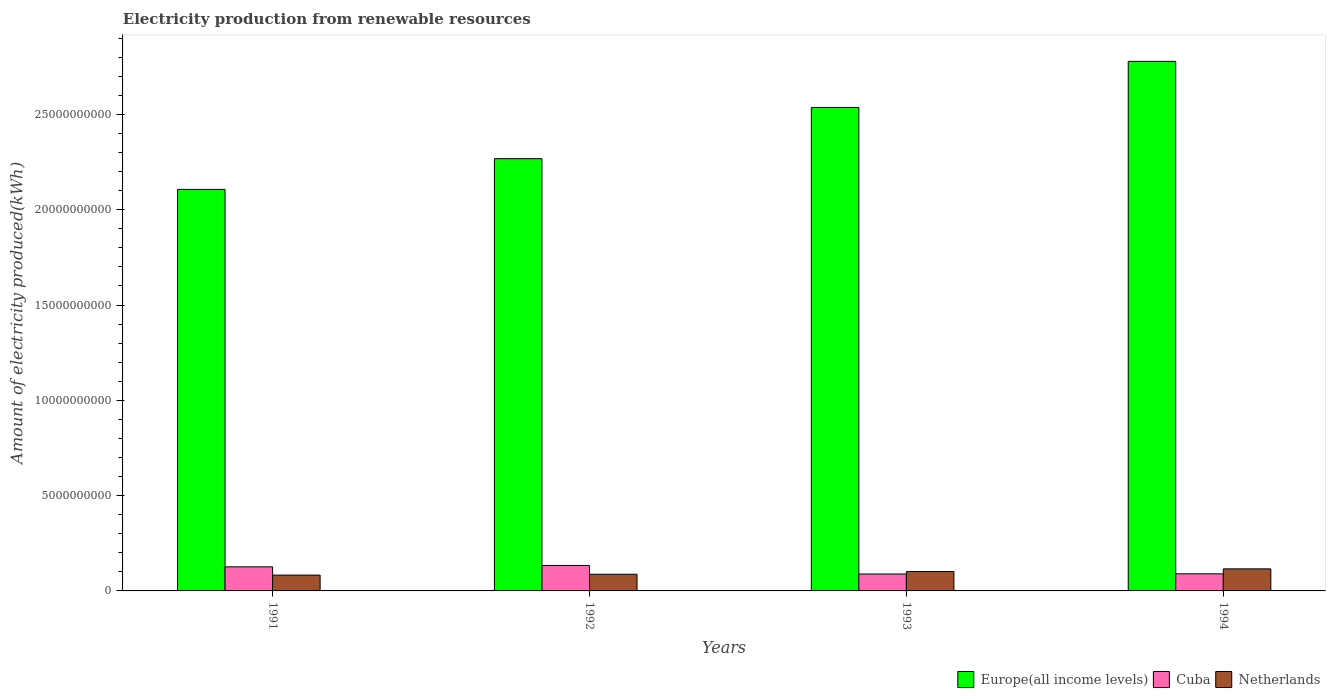Are the number of bars on each tick of the X-axis equal?
Make the answer very short. Yes. How many bars are there on the 2nd tick from the right?
Provide a short and direct response. 3. What is the amount of electricity produced in Netherlands in 1991?
Your response must be concise. 8.30e+08. Across all years, what is the maximum amount of electricity produced in Netherlands?
Your answer should be compact. 1.16e+09. Across all years, what is the minimum amount of electricity produced in Cuba?
Offer a very short reply. 8.87e+08. In which year was the amount of electricity produced in Europe(all income levels) maximum?
Offer a terse response. 1994. What is the total amount of electricity produced in Europe(all income levels) in the graph?
Your response must be concise. 9.69e+1. What is the difference between the amount of electricity produced in Netherlands in 1991 and that in 1994?
Keep it short and to the point. -3.27e+08. What is the difference between the amount of electricity produced in Europe(all income levels) in 1991 and the amount of electricity produced in Cuba in 1994?
Provide a succinct answer. 2.02e+1. What is the average amount of electricity produced in Netherlands per year?
Keep it short and to the point. 9.69e+08. In the year 1993, what is the difference between the amount of electricity produced in Europe(all income levels) and amount of electricity produced in Netherlands?
Make the answer very short. 2.44e+1. In how many years, is the amount of electricity produced in Europe(all income levels) greater than 20000000000 kWh?
Make the answer very short. 4. What is the ratio of the amount of electricity produced in Netherlands in 1993 to that in 1994?
Ensure brevity in your answer.  0.88. Is the difference between the amount of electricity produced in Europe(all income levels) in 1991 and 1992 greater than the difference between the amount of electricity produced in Netherlands in 1991 and 1992?
Ensure brevity in your answer.  No. What is the difference between the highest and the second highest amount of electricity produced in Netherlands?
Give a very brief answer. 1.42e+08. What is the difference between the highest and the lowest amount of electricity produced in Netherlands?
Ensure brevity in your answer.  3.27e+08. What does the 1st bar from the left in 1992 represents?
Make the answer very short. Europe(all income levels). What does the 2nd bar from the right in 1992 represents?
Provide a succinct answer. Cuba. Is it the case that in every year, the sum of the amount of electricity produced in Netherlands and amount of electricity produced in Europe(all income levels) is greater than the amount of electricity produced in Cuba?
Provide a short and direct response. Yes. How many bars are there?
Give a very brief answer. 12. Are all the bars in the graph horizontal?
Offer a terse response. No. How many years are there in the graph?
Provide a succinct answer. 4. Are the values on the major ticks of Y-axis written in scientific E-notation?
Your response must be concise. No. Does the graph contain any zero values?
Offer a very short reply. No. Does the graph contain grids?
Your answer should be very brief. No. How many legend labels are there?
Provide a succinct answer. 3. How are the legend labels stacked?
Offer a terse response. Horizontal. What is the title of the graph?
Ensure brevity in your answer.  Electricity production from renewable resources. What is the label or title of the Y-axis?
Make the answer very short. Amount of electricity produced(kWh). What is the Amount of electricity produced(kWh) of Europe(all income levels) in 1991?
Keep it short and to the point. 2.11e+1. What is the Amount of electricity produced(kWh) in Cuba in 1991?
Your answer should be very brief. 1.26e+09. What is the Amount of electricity produced(kWh) in Netherlands in 1991?
Give a very brief answer. 8.30e+08. What is the Amount of electricity produced(kWh) of Europe(all income levels) in 1992?
Ensure brevity in your answer.  2.27e+1. What is the Amount of electricity produced(kWh) in Cuba in 1992?
Offer a terse response. 1.34e+09. What is the Amount of electricity produced(kWh) in Netherlands in 1992?
Offer a terse response. 8.75e+08. What is the Amount of electricity produced(kWh) of Europe(all income levels) in 1993?
Give a very brief answer. 2.54e+1. What is the Amount of electricity produced(kWh) in Cuba in 1993?
Give a very brief answer. 8.87e+08. What is the Amount of electricity produced(kWh) of Netherlands in 1993?
Offer a terse response. 1.02e+09. What is the Amount of electricity produced(kWh) in Europe(all income levels) in 1994?
Provide a succinct answer. 2.78e+1. What is the Amount of electricity produced(kWh) in Cuba in 1994?
Give a very brief answer. 8.97e+08. What is the Amount of electricity produced(kWh) of Netherlands in 1994?
Provide a short and direct response. 1.16e+09. Across all years, what is the maximum Amount of electricity produced(kWh) in Europe(all income levels)?
Ensure brevity in your answer.  2.78e+1. Across all years, what is the maximum Amount of electricity produced(kWh) of Cuba?
Your answer should be compact. 1.34e+09. Across all years, what is the maximum Amount of electricity produced(kWh) in Netherlands?
Your answer should be very brief. 1.16e+09. Across all years, what is the minimum Amount of electricity produced(kWh) in Europe(all income levels)?
Provide a succinct answer. 2.11e+1. Across all years, what is the minimum Amount of electricity produced(kWh) of Cuba?
Give a very brief answer. 8.87e+08. Across all years, what is the minimum Amount of electricity produced(kWh) of Netherlands?
Your response must be concise. 8.30e+08. What is the total Amount of electricity produced(kWh) of Europe(all income levels) in the graph?
Your response must be concise. 9.69e+1. What is the total Amount of electricity produced(kWh) of Cuba in the graph?
Keep it short and to the point. 4.38e+09. What is the total Amount of electricity produced(kWh) of Netherlands in the graph?
Provide a succinct answer. 3.88e+09. What is the difference between the Amount of electricity produced(kWh) in Europe(all income levels) in 1991 and that in 1992?
Provide a succinct answer. -1.61e+09. What is the difference between the Amount of electricity produced(kWh) in Cuba in 1991 and that in 1992?
Keep it short and to the point. -7.30e+07. What is the difference between the Amount of electricity produced(kWh) of Netherlands in 1991 and that in 1992?
Give a very brief answer. -4.50e+07. What is the difference between the Amount of electricity produced(kWh) of Europe(all income levels) in 1991 and that in 1993?
Give a very brief answer. -4.30e+09. What is the difference between the Amount of electricity produced(kWh) in Cuba in 1991 and that in 1993?
Your answer should be compact. 3.77e+08. What is the difference between the Amount of electricity produced(kWh) of Netherlands in 1991 and that in 1993?
Make the answer very short. -1.85e+08. What is the difference between the Amount of electricity produced(kWh) of Europe(all income levels) in 1991 and that in 1994?
Give a very brief answer. -6.72e+09. What is the difference between the Amount of electricity produced(kWh) of Cuba in 1991 and that in 1994?
Offer a very short reply. 3.67e+08. What is the difference between the Amount of electricity produced(kWh) of Netherlands in 1991 and that in 1994?
Offer a very short reply. -3.27e+08. What is the difference between the Amount of electricity produced(kWh) in Europe(all income levels) in 1992 and that in 1993?
Keep it short and to the point. -2.69e+09. What is the difference between the Amount of electricity produced(kWh) of Cuba in 1992 and that in 1993?
Offer a very short reply. 4.50e+08. What is the difference between the Amount of electricity produced(kWh) in Netherlands in 1992 and that in 1993?
Offer a terse response. -1.40e+08. What is the difference between the Amount of electricity produced(kWh) of Europe(all income levels) in 1992 and that in 1994?
Ensure brevity in your answer.  -5.11e+09. What is the difference between the Amount of electricity produced(kWh) of Cuba in 1992 and that in 1994?
Provide a short and direct response. 4.40e+08. What is the difference between the Amount of electricity produced(kWh) of Netherlands in 1992 and that in 1994?
Keep it short and to the point. -2.82e+08. What is the difference between the Amount of electricity produced(kWh) in Europe(all income levels) in 1993 and that in 1994?
Give a very brief answer. -2.42e+09. What is the difference between the Amount of electricity produced(kWh) in Cuba in 1993 and that in 1994?
Keep it short and to the point. -1.00e+07. What is the difference between the Amount of electricity produced(kWh) of Netherlands in 1993 and that in 1994?
Keep it short and to the point. -1.42e+08. What is the difference between the Amount of electricity produced(kWh) in Europe(all income levels) in 1991 and the Amount of electricity produced(kWh) in Cuba in 1992?
Ensure brevity in your answer.  1.97e+1. What is the difference between the Amount of electricity produced(kWh) in Europe(all income levels) in 1991 and the Amount of electricity produced(kWh) in Netherlands in 1992?
Provide a short and direct response. 2.02e+1. What is the difference between the Amount of electricity produced(kWh) in Cuba in 1991 and the Amount of electricity produced(kWh) in Netherlands in 1992?
Your answer should be very brief. 3.89e+08. What is the difference between the Amount of electricity produced(kWh) in Europe(all income levels) in 1991 and the Amount of electricity produced(kWh) in Cuba in 1993?
Your response must be concise. 2.02e+1. What is the difference between the Amount of electricity produced(kWh) in Europe(all income levels) in 1991 and the Amount of electricity produced(kWh) in Netherlands in 1993?
Your response must be concise. 2.01e+1. What is the difference between the Amount of electricity produced(kWh) in Cuba in 1991 and the Amount of electricity produced(kWh) in Netherlands in 1993?
Your answer should be very brief. 2.49e+08. What is the difference between the Amount of electricity produced(kWh) in Europe(all income levels) in 1991 and the Amount of electricity produced(kWh) in Cuba in 1994?
Give a very brief answer. 2.02e+1. What is the difference between the Amount of electricity produced(kWh) in Europe(all income levels) in 1991 and the Amount of electricity produced(kWh) in Netherlands in 1994?
Your answer should be compact. 1.99e+1. What is the difference between the Amount of electricity produced(kWh) of Cuba in 1991 and the Amount of electricity produced(kWh) of Netherlands in 1994?
Offer a very short reply. 1.07e+08. What is the difference between the Amount of electricity produced(kWh) in Europe(all income levels) in 1992 and the Amount of electricity produced(kWh) in Cuba in 1993?
Offer a very short reply. 2.18e+1. What is the difference between the Amount of electricity produced(kWh) of Europe(all income levels) in 1992 and the Amount of electricity produced(kWh) of Netherlands in 1993?
Make the answer very short. 2.17e+1. What is the difference between the Amount of electricity produced(kWh) in Cuba in 1992 and the Amount of electricity produced(kWh) in Netherlands in 1993?
Provide a succinct answer. 3.22e+08. What is the difference between the Amount of electricity produced(kWh) in Europe(all income levels) in 1992 and the Amount of electricity produced(kWh) in Cuba in 1994?
Offer a very short reply. 2.18e+1. What is the difference between the Amount of electricity produced(kWh) of Europe(all income levels) in 1992 and the Amount of electricity produced(kWh) of Netherlands in 1994?
Provide a short and direct response. 2.15e+1. What is the difference between the Amount of electricity produced(kWh) of Cuba in 1992 and the Amount of electricity produced(kWh) of Netherlands in 1994?
Provide a succinct answer. 1.80e+08. What is the difference between the Amount of electricity produced(kWh) of Europe(all income levels) in 1993 and the Amount of electricity produced(kWh) of Cuba in 1994?
Your answer should be very brief. 2.45e+1. What is the difference between the Amount of electricity produced(kWh) of Europe(all income levels) in 1993 and the Amount of electricity produced(kWh) of Netherlands in 1994?
Provide a short and direct response. 2.42e+1. What is the difference between the Amount of electricity produced(kWh) in Cuba in 1993 and the Amount of electricity produced(kWh) in Netherlands in 1994?
Your answer should be compact. -2.70e+08. What is the average Amount of electricity produced(kWh) of Europe(all income levels) per year?
Ensure brevity in your answer.  2.42e+1. What is the average Amount of electricity produced(kWh) of Cuba per year?
Provide a succinct answer. 1.10e+09. What is the average Amount of electricity produced(kWh) of Netherlands per year?
Keep it short and to the point. 9.69e+08. In the year 1991, what is the difference between the Amount of electricity produced(kWh) in Europe(all income levels) and Amount of electricity produced(kWh) in Cuba?
Offer a very short reply. 1.98e+1. In the year 1991, what is the difference between the Amount of electricity produced(kWh) in Europe(all income levels) and Amount of electricity produced(kWh) in Netherlands?
Offer a very short reply. 2.02e+1. In the year 1991, what is the difference between the Amount of electricity produced(kWh) of Cuba and Amount of electricity produced(kWh) of Netherlands?
Provide a succinct answer. 4.34e+08. In the year 1992, what is the difference between the Amount of electricity produced(kWh) of Europe(all income levels) and Amount of electricity produced(kWh) of Cuba?
Offer a terse response. 2.13e+1. In the year 1992, what is the difference between the Amount of electricity produced(kWh) of Europe(all income levels) and Amount of electricity produced(kWh) of Netherlands?
Ensure brevity in your answer.  2.18e+1. In the year 1992, what is the difference between the Amount of electricity produced(kWh) of Cuba and Amount of electricity produced(kWh) of Netherlands?
Provide a short and direct response. 4.62e+08. In the year 1993, what is the difference between the Amount of electricity produced(kWh) of Europe(all income levels) and Amount of electricity produced(kWh) of Cuba?
Ensure brevity in your answer.  2.45e+1. In the year 1993, what is the difference between the Amount of electricity produced(kWh) in Europe(all income levels) and Amount of electricity produced(kWh) in Netherlands?
Ensure brevity in your answer.  2.44e+1. In the year 1993, what is the difference between the Amount of electricity produced(kWh) in Cuba and Amount of electricity produced(kWh) in Netherlands?
Your response must be concise. -1.28e+08. In the year 1994, what is the difference between the Amount of electricity produced(kWh) of Europe(all income levels) and Amount of electricity produced(kWh) of Cuba?
Your answer should be very brief. 2.69e+1. In the year 1994, what is the difference between the Amount of electricity produced(kWh) in Europe(all income levels) and Amount of electricity produced(kWh) in Netherlands?
Your response must be concise. 2.66e+1. In the year 1994, what is the difference between the Amount of electricity produced(kWh) of Cuba and Amount of electricity produced(kWh) of Netherlands?
Your answer should be compact. -2.60e+08. What is the ratio of the Amount of electricity produced(kWh) in Europe(all income levels) in 1991 to that in 1992?
Provide a short and direct response. 0.93. What is the ratio of the Amount of electricity produced(kWh) of Cuba in 1991 to that in 1992?
Make the answer very short. 0.95. What is the ratio of the Amount of electricity produced(kWh) in Netherlands in 1991 to that in 1992?
Keep it short and to the point. 0.95. What is the ratio of the Amount of electricity produced(kWh) in Europe(all income levels) in 1991 to that in 1993?
Keep it short and to the point. 0.83. What is the ratio of the Amount of electricity produced(kWh) of Cuba in 1991 to that in 1993?
Your response must be concise. 1.43. What is the ratio of the Amount of electricity produced(kWh) in Netherlands in 1991 to that in 1993?
Keep it short and to the point. 0.82. What is the ratio of the Amount of electricity produced(kWh) in Europe(all income levels) in 1991 to that in 1994?
Ensure brevity in your answer.  0.76. What is the ratio of the Amount of electricity produced(kWh) in Cuba in 1991 to that in 1994?
Your answer should be very brief. 1.41. What is the ratio of the Amount of electricity produced(kWh) of Netherlands in 1991 to that in 1994?
Your answer should be compact. 0.72. What is the ratio of the Amount of electricity produced(kWh) in Europe(all income levels) in 1992 to that in 1993?
Your answer should be compact. 0.89. What is the ratio of the Amount of electricity produced(kWh) of Cuba in 1992 to that in 1993?
Provide a short and direct response. 1.51. What is the ratio of the Amount of electricity produced(kWh) in Netherlands in 1992 to that in 1993?
Your answer should be compact. 0.86. What is the ratio of the Amount of electricity produced(kWh) in Europe(all income levels) in 1992 to that in 1994?
Offer a terse response. 0.82. What is the ratio of the Amount of electricity produced(kWh) in Cuba in 1992 to that in 1994?
Provide a short and direct response. 1.49. What is the ratio of the Amount of electricity produced(kWh) in Netherlands in 1992 to that in 1994?
Your answer should be compact. 0.76. What is the ratio of the Amount of electricity produced(kWh) in Europe(all income levels) in 1993 to that in 1994?
Make the answer very short. 0.91. What is the ratio of the Amount of electricity produced(kWh) of Cuba in 1993 to that in 1994?
Keep it short and to the point. 0.99. What is the ratio of the Amount of electricity produced(kWh) in Netherlands in 1993 to that in 1994?
Offer a very short reply. 0.88. What is the difference between the highest and the second highest Amount of electricity produced(kWh) in Europe(all income levels)?
Provide a succinct answer. 2.42e+09. What is the difference between the highest and the second highest Amount of electricity produced(kWh) in Cuba?
Keep it short and to the point. 7.30e+07. What is the difference between the highest and the second highest Amount of electricity produced(kWh) of Netherlands?
Your answer should be compact. 1.42e+08. What is the difference between the highest and the lowest Amount of electricity produced(kWh) of Europe(all income levels)?
Your response must be concise. 6.72e+09. What is the difference between the highest and the lowest Amount of electricity produced(kWh) of Cuba?
Provide a succinct answer. 4.50e+08. What is the difference between the highest and the lowest Amount of electricity produced(kWh) of Netherlands?
Offer a terse response. 3.27e+08. 